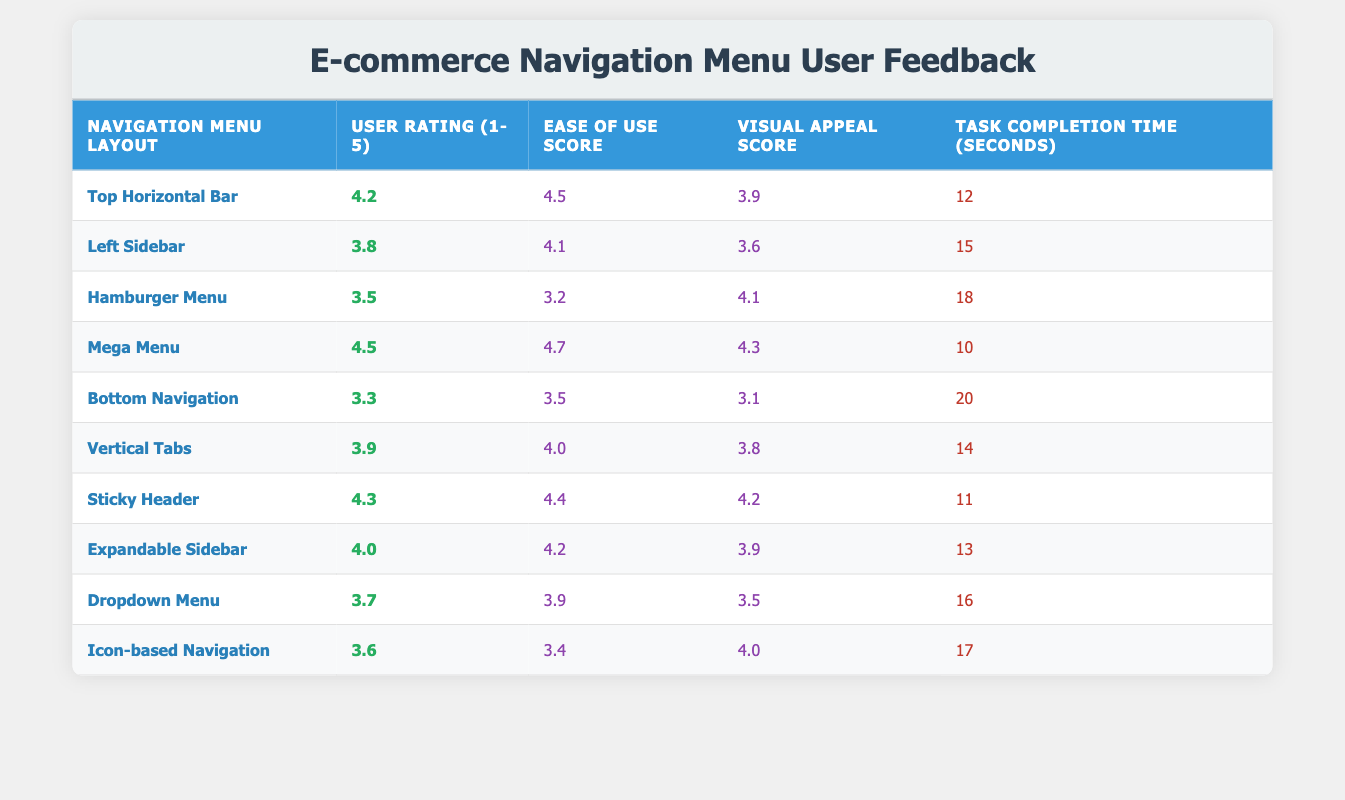What is the user rating for the Mega Menu layout? The table lists the user rating for the Mega Menu layout in the second column. It shows a user rating of 4.5.
Answer: 4.5 Which navigation menu layout has the highest Ease of Use Score? Looking at the Ease of Use Score column, the Mega Menu has the highest score of 4.7, which can be identified by scanning the values.
Answer: Mega Menu What is the average Task Completion Time across all navigation layouts? To find the average Task Completion Time, sum all the completion times (12 + 15 + 18 + 10 + 20 + 14 + 11 + 13 + 16 + 17 =  156) which provides a total of 156 seconds. Then, divide this total by the number of layouts (10): 156 / 10 = 15.6 seconds.
Answer: 15.6 seconds Is the Sticky Header layout rated higher than the Icon-based Navigation layout in both User Rating and Visual Appeal Score? Check the ratings for both layouts. The Sticky Header has a user rating of 4.3 and a visual appeal score of 4.2, whereas the Icon-based Navigation has a user rating of 3.6 and a visual appeal score of 4.0. Since both scores for the Sticky Header are higher than those for the Icon-based Navigation, the answer is yes.
Answer: Yes Which two navigation layouts have the lowest combined rating from the User Rating and Visual Appeal Score? For each layout, add the user rating and visual appeal score. For Bottom Navigation, the combined score is 3.3 + 3.1 = 6.4. For Hamburger Menu, it's 3.5 + 4.1 = 7.6. Calculate similarly for others. The Bottom Navigation (6.4) and Icon-based Navigation (7.6) yield the lowest combined scores, making them the layouts in question.
Answer: Bottom Navigation and Icon-based Navigation 